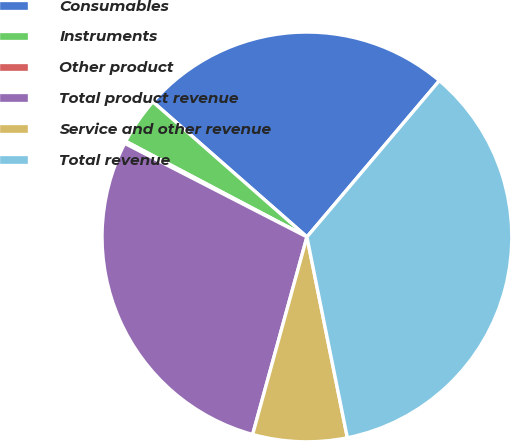Convert chart. <chart><loc_0><loc_0><loc_500><loc_500><pie_chart><fcel>Consumables<fcel>Instruments<fcel>Other product<fcel>Total product revenue<fcel>Service and other revenue<fcel>Total revenue<nl><fcel>24.73%<fcel>3.73%<fcel>0.18%<fcel>28.28%<fcel>7.43%<fcel>35.65%<nl></chart> 